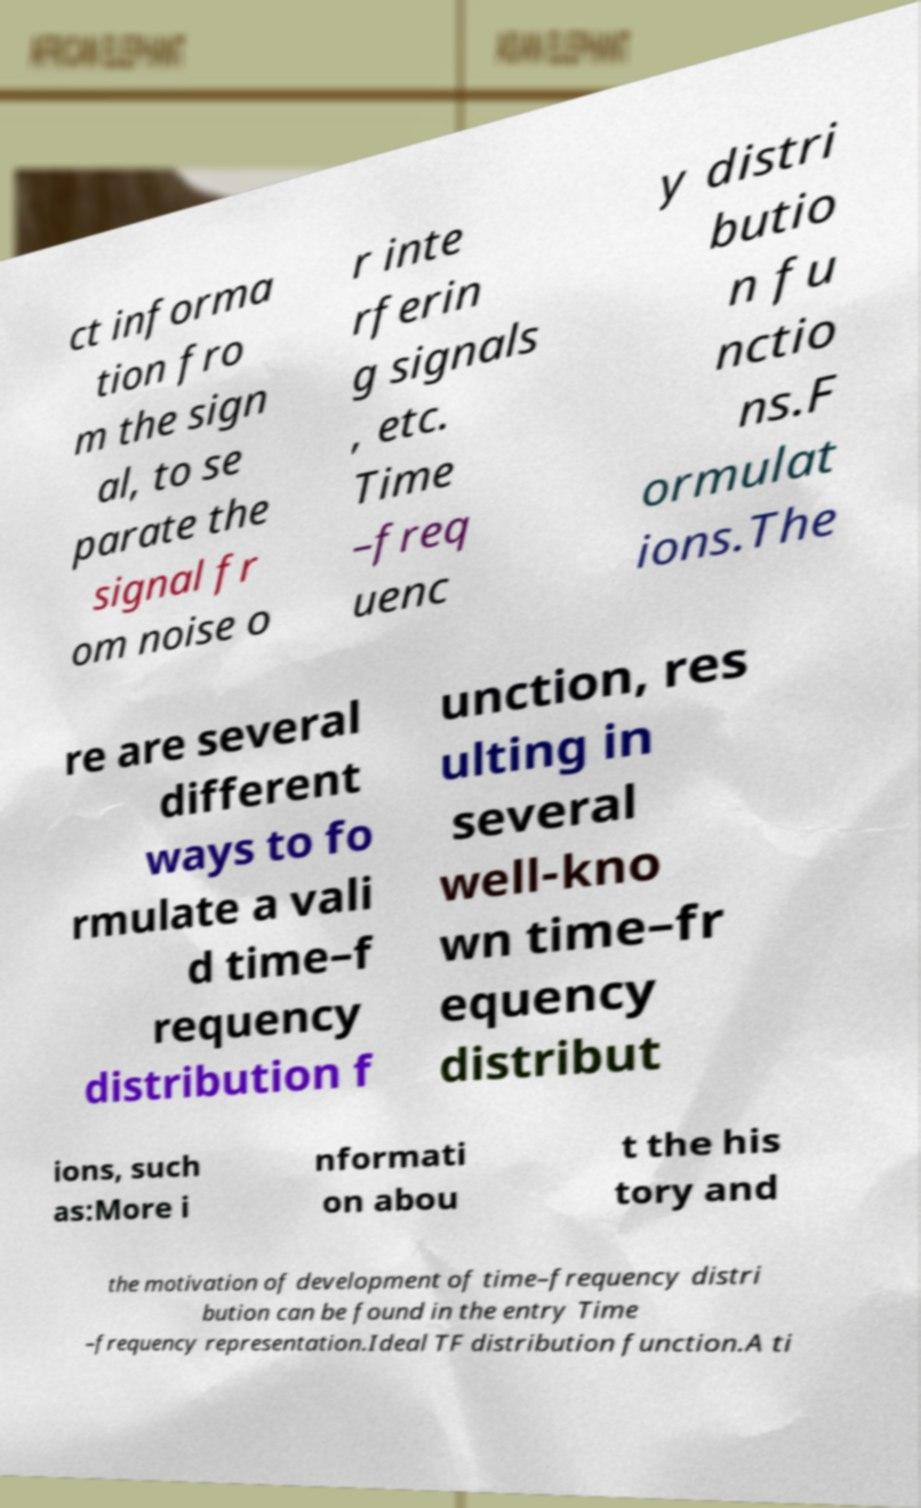Could you assist in decoding the text presented in this image and type it out clearly? ct informa tion fro m the sign al, to se parate the signal fr om noise o r inte rferin g signals , etc. Time –freq uenc y distri butio n fu nctio ns.F ormulat ions.The re are several different ways to fo rmulate a vali d time–f requency distribution f unction, res ulting in several well-kno wn time–fr equency distribut ions, such as:More i nformati on abou t the his tory and the motivation of development of time–frequency distri bution can be found in the entry Time –frequency representation.Ideal TF distribution function.A ti 